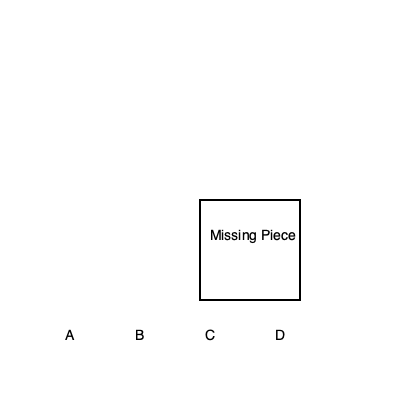Which jigsaw puzzle piece correctly completes the image of Scott Norwood's infamous "Wide Right" field goal attempt in Super Bowl XXV? 1. Examine the main image, which shows the crucial moment of Scott Norwood's field goal attempt in Super Bowl XXV against the New York Giants.
2. Notice the missing piece in the lower right corner of the main image.
3. Analyze the four potential puzzle pieces labeled A, B, C, and D.
4. Piece A shows part of the field, but it doesn't match the angle or perspective of the missing area.
5. Piece B contains part of the goalpost, which is not present in the missing area.
6. Piece C shows Norwood's kicking leg and part of the ball, which aligns with the trajectory and positioning of the main image.
7. Piece D depicts spectators, which are not visible in the area surrounding the missing piece.
8. Based on the alignment, content, and perspective, piece C is the correct match to complete the image of this pivotal moment in Bills history.
Answer: C 